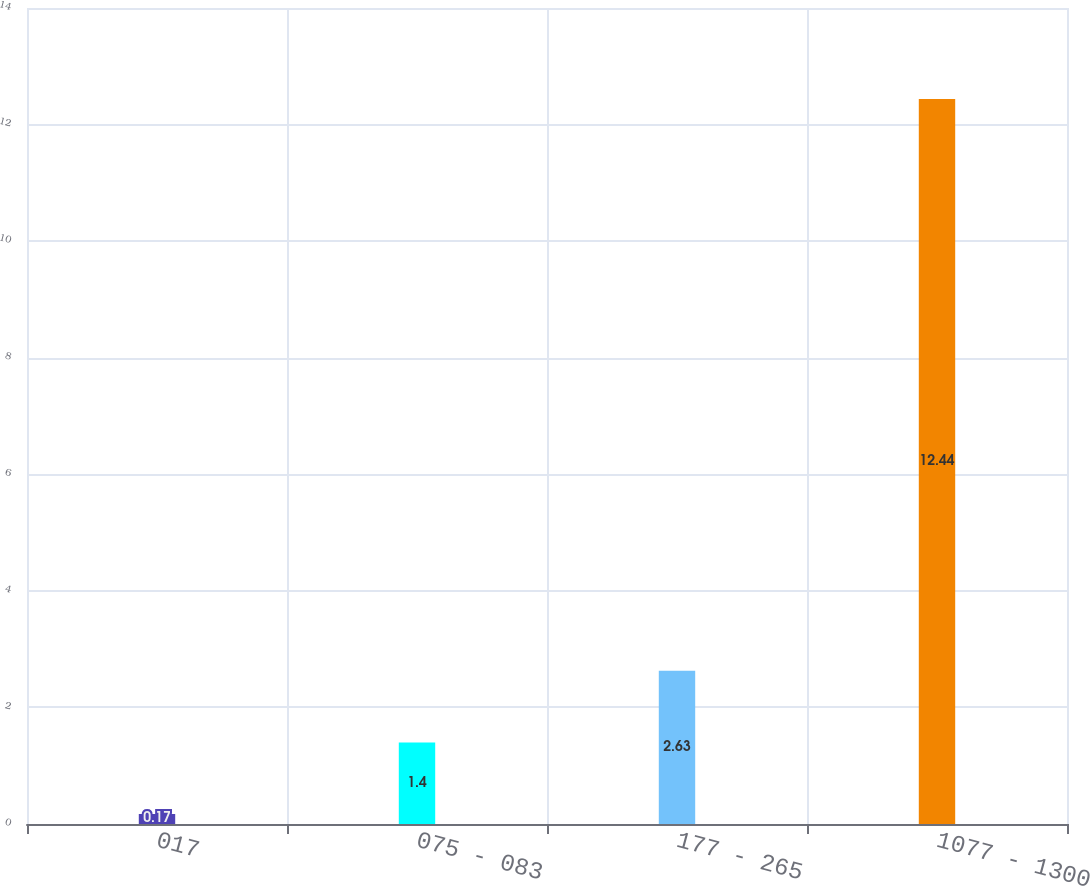Convert chart to OTSL. <chart><loc_0><loc_0><loc_500><loc_500><bar_chart><fcel>017<fcel>075 - 083<fcel>177 - 265<fcel>1077 - 1300<nl><fcel>0.17<fcel>1.4<fcel>2.63<fcel>12.44<nl></chart> 